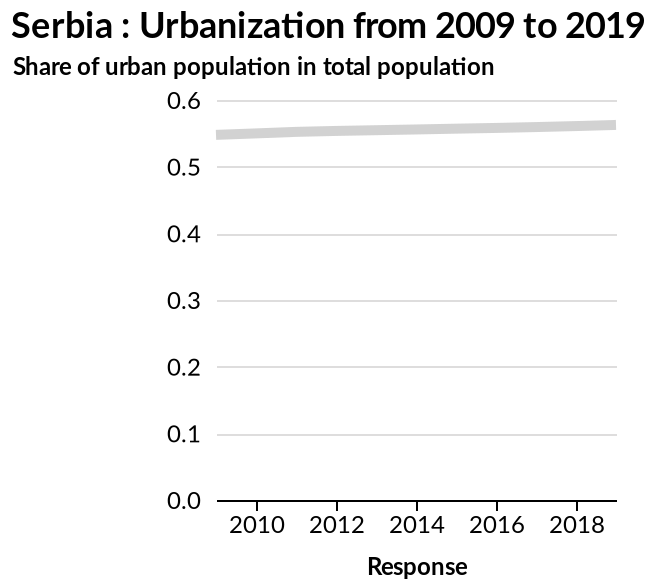<image>
Is the share of urbanization increasing?  Yes, the share of urbanization is steadily increasing. Is the increase in urbanization happening at a fast rate?  No, the increase in urbanization is happening slowly, but not by much. What is marked along the x-axis of the line plot? The x-axis is marked "Response". What is defined on the y-axis of the line plot?  The share of urban population in total population is defined on the y-axis. 